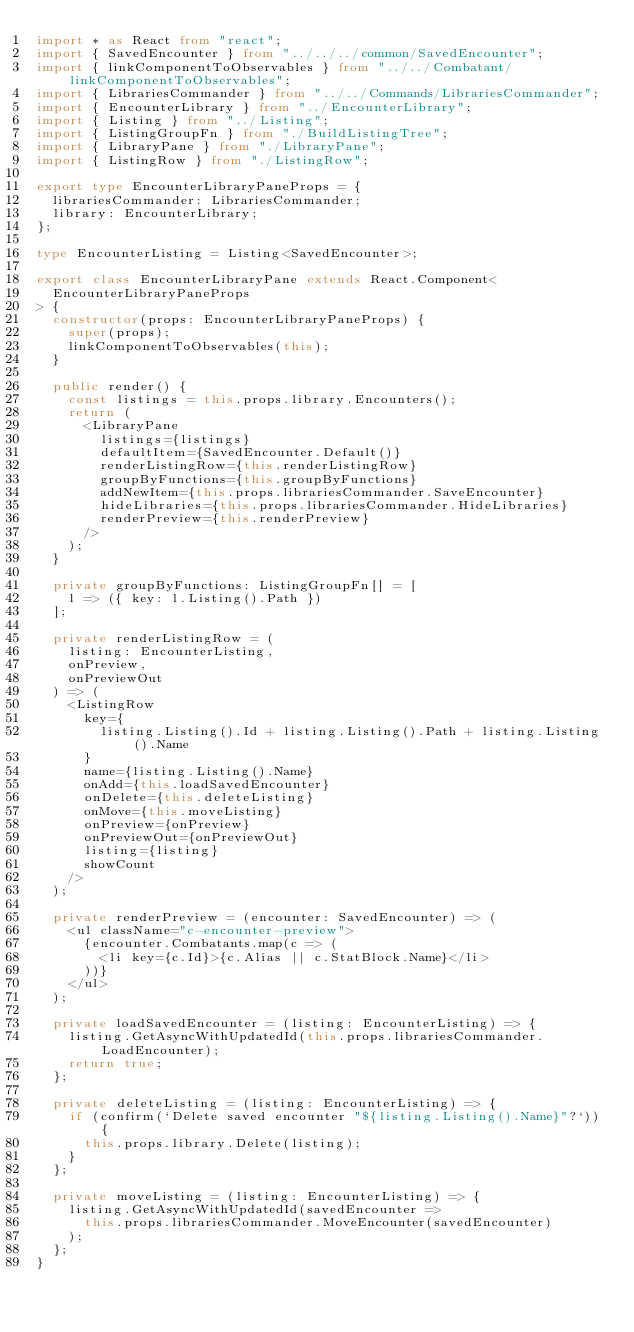Convert code to text. <code><loc_0><loc_0><loc_500><loc_500><_TypeScript_>import * as React from "react";
import { SavedEncounter } from "../../../common/SavedEncounter";
import { linkComponentToObservables } from "../../Combatant/linkComponentToObservables";
import { LibrariesCommander } from "../../Commands/LibrariesCommander";
import { EncounterLibrary } from "../EncounterLibrary";
import { Listing } from "../Listing";
import { ListingGroupFn } from "./BuildListingTree";
import { LibraryPane } from "./LibraryPane";
import { ListingRow } from "./ListingRow";

export type EncounterLibraryPaneProps = {
  librariesCommander: LibrariesCommander;
  library: EncounterLibrary;
};

type EncounterListing = Listing<SavedEncounter>;

export class EncounterLibraryPane extends React.Component<
  EncounterLibraryPaneProps
> {
  constructor(props: EncounterLibraryPaneProps) {
    super(props);
    linkComponentToObservables(this);
  }

  public render() {
    const listings = this.props.library.Encounters();
    return (
      <LibraryPane
        listings={listings}
        defaultItem={SavedEncounter.Default()}
        renderListingRow={this.renderListingRow}
        groupByFunctions={this.groupByFunctions}
        addNewItem={this.props.librariesCommander.SaveEncounter}
        hideLibraries={this.props.librariesCommander.HideLibraries}
        renderPreview={this.renderPreview}
      />
    );
  }

  private groupByFunctions: ListingGroupFn[] = [
    l => ({ key: l.Listing().Path })
  ];

  private renderListingRow = (
    listing: EncounterListing,
    onPreview,
    onPreviewOut
  ) => (
    <ListingRow
      key={
        listing.Listing().Id + listing.Listing().Path + listing.Listing().Name
      }
      name={listing.Listing().Name}
      onAdd={this.loadSavedEncounter}
      onDelete={this.deleteListing}
      onMove={this.moveListing}
      onPreview={onPreview}
      onPreviewOut={onPreviewOut}
      listing={listing}
      showCount
    />
  );

  private renderPreview = (encounter: SavedEncounter) => (
    <ul className="c-encounter-preview">
      {encounter.Combatants.map(c => (
        <li key={c.Id}>{c.Alias || c.StatBlock.Name}</li>
      ))}
    </ul>
  );

  private loadSavedEncounter = (listing: EncounterListing) => {
    listing.GetAsyncWithUpdatedId(this.props.librariesCommander.LoadEncounter);
    return true;
  };

  private deleteListing = (listing: EncounterListing) => {
    if (confirm(`Delete saved encounter "${listing.Listing().Name}"?`)) {
      this.props.library.Delete(listing);
    }
  };

  private moveListing = (listing: EncounterListing) => {
    listing.GetAsyncWithUpdatedId(savedEncounter =>
      this.props.librariesCommander.MoveEncounter(savedEncounter)
    );
  };
}
</code> 